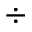<formula> <loc_0><loc_0><loc_500><loc_500>\div</formula> 